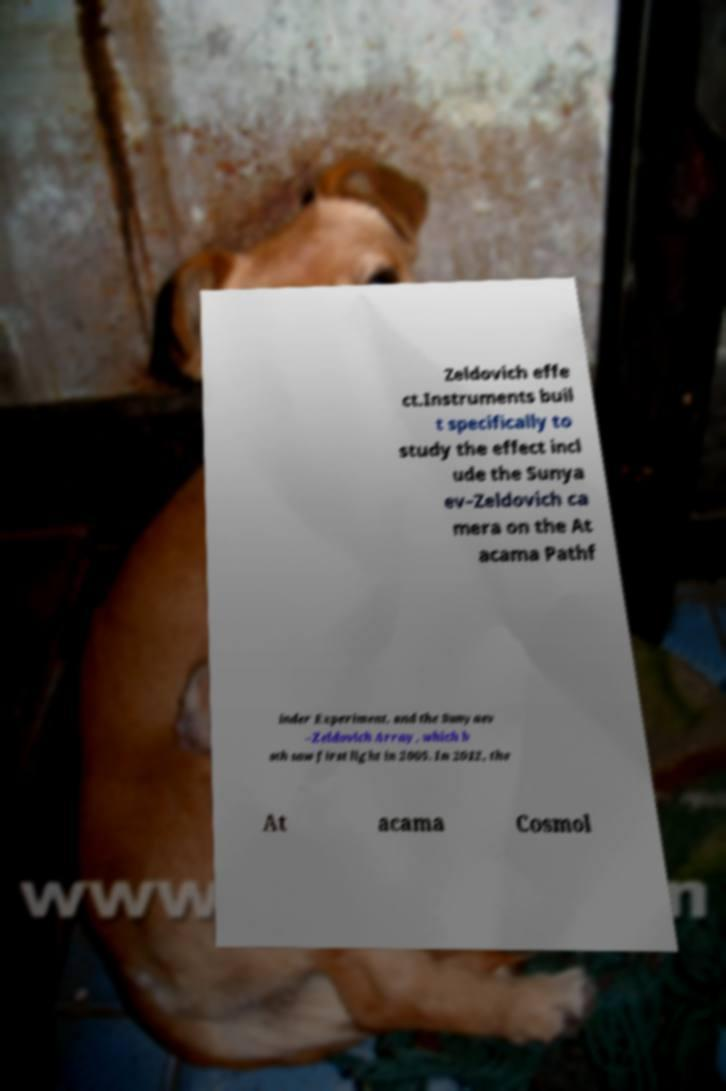Can you read and provide the text displayed in the image?This photo seems to have some interesting text. Can you extract and type it out for me? Zeldovich effe ct.Instruments buil t specifically to study the effect incl ude the Sunya ev–Zeldovich ca mera on the At acama Pathf inder Experiment, and the Sunyaev –Zeldovich Array, which b oth saw first light in 2005. In 2012, the At acama Cosmol 